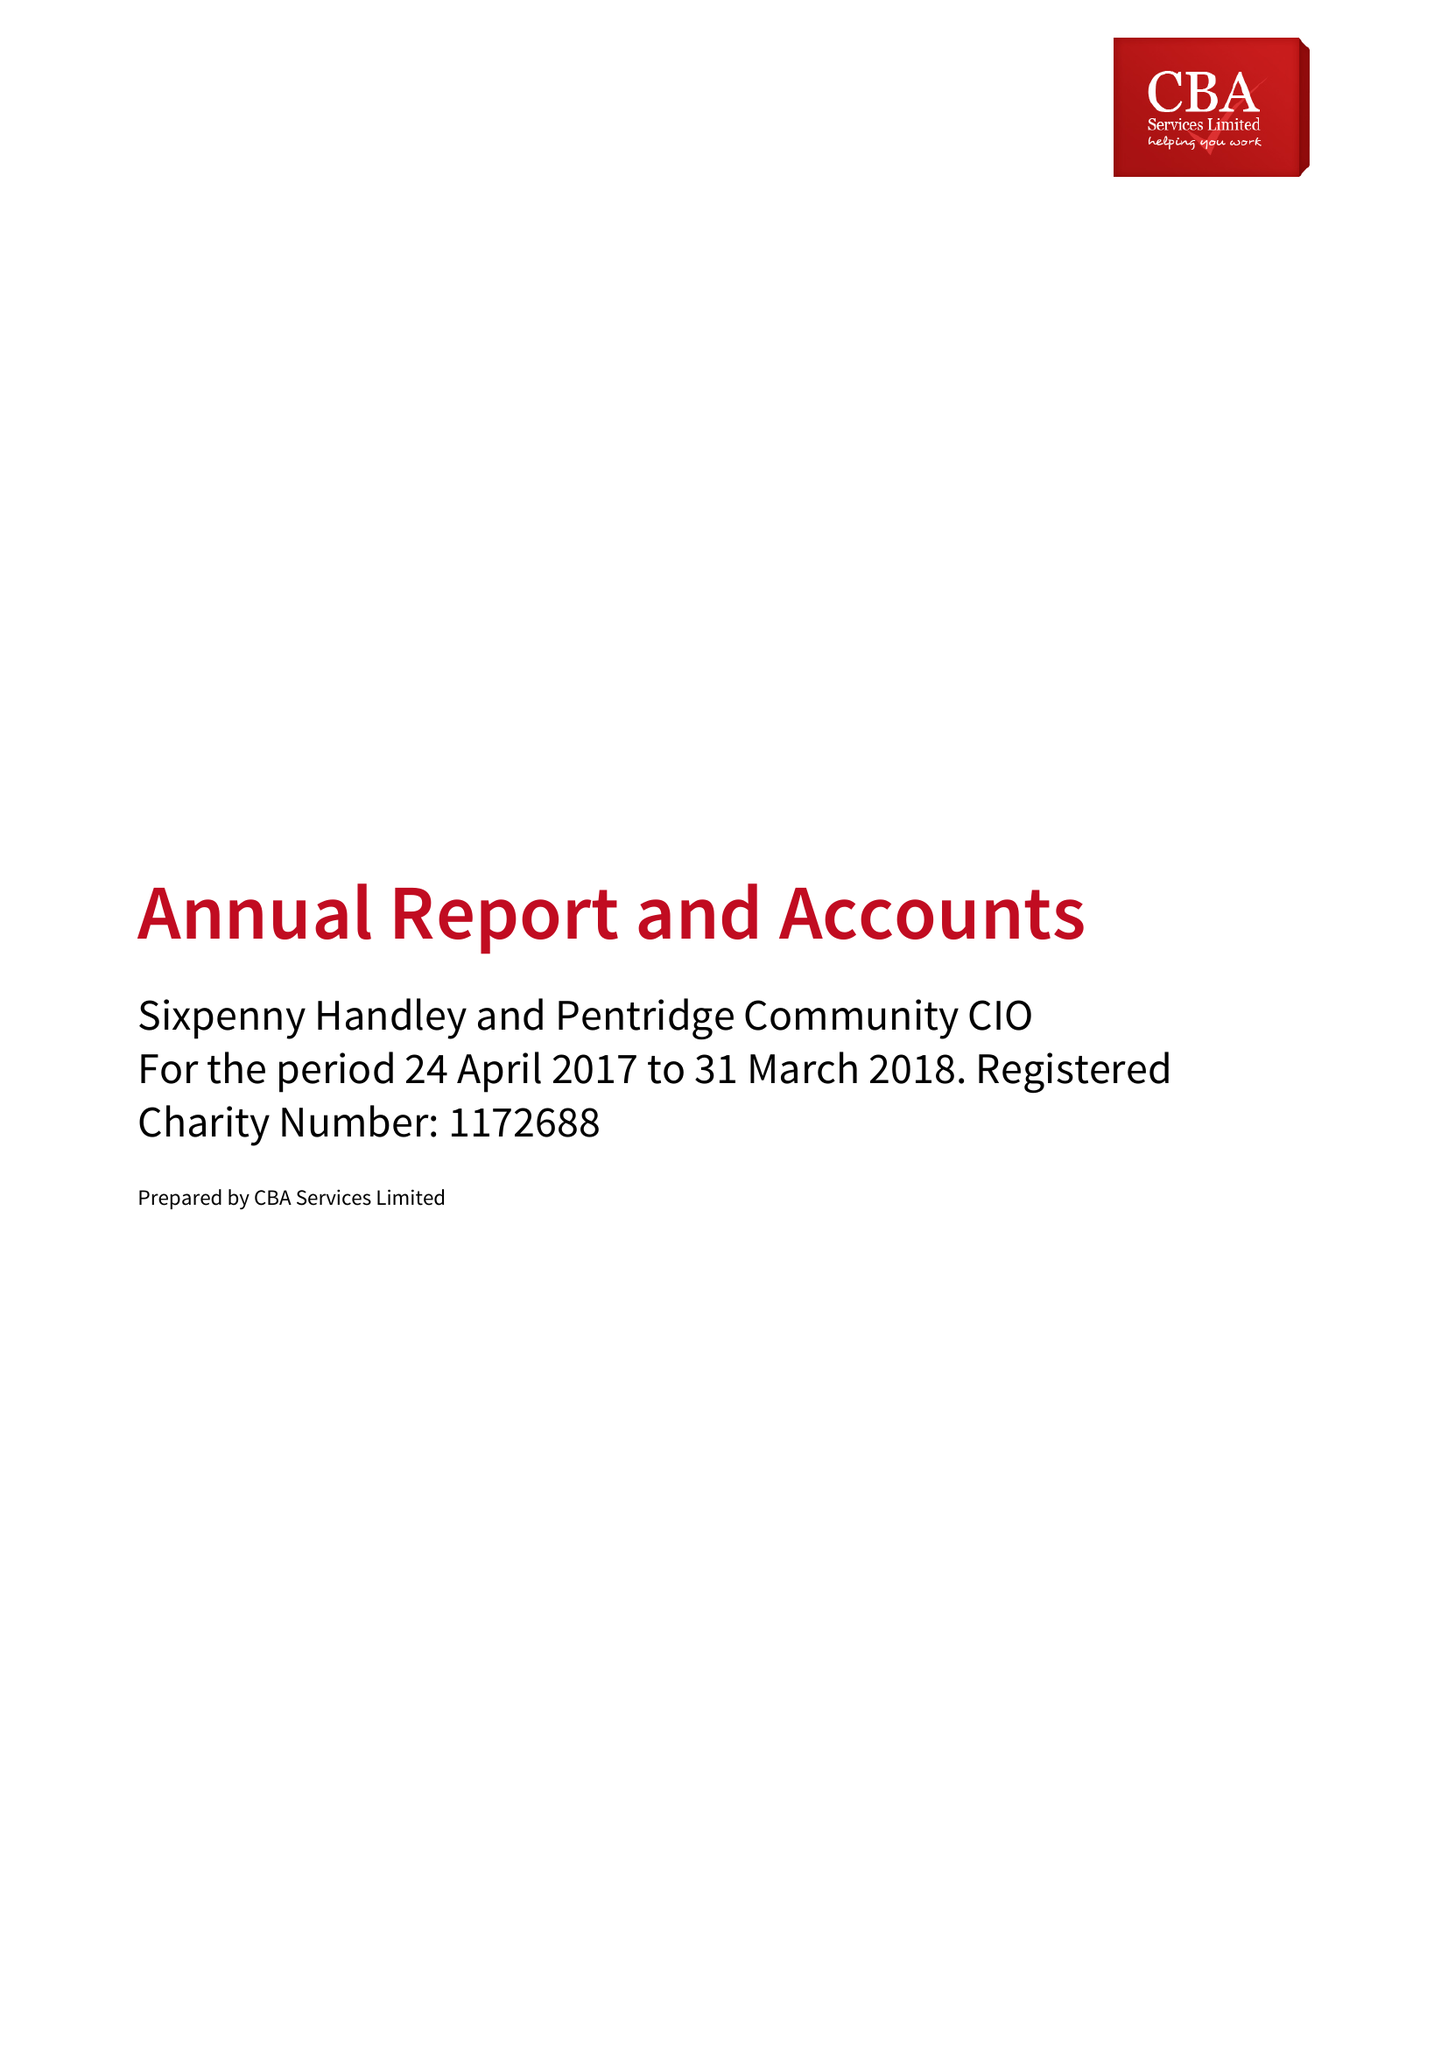What is the value for the address__street_line?
Answer the question using a single word or phrase. DEAN LANE 